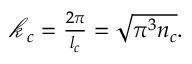<formula> <loc_0><loc_0><loc_500><loc_500>\begin{array} { r } { \mathcal { k } _ { c } = \frac { 2 \pi } { l _ { c } } = \sqrt { \pi ^ { 3 } n _ { c } } . } \end{array}</formula> 